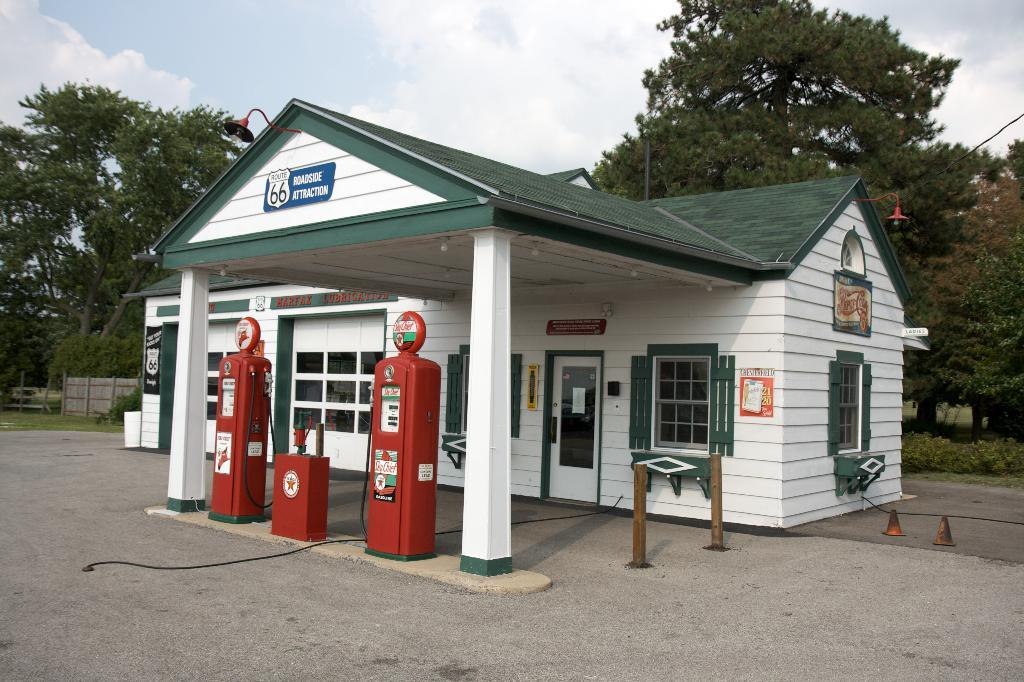What type of building is visible in the image? There is a house in the image. What feature of the house is visible? There is a window and a door in the image. What other structure can be seen in the image? There is a gas station in the image. What type of vegetation is present in the image? There are trees and grass in the image. How would you describe the weather in the image? The sky is cloudy in the image. What type of kettle is being used to control the temper of the trees in the image? There is no kettle or indication of controlling the temper of the trees in the image. 